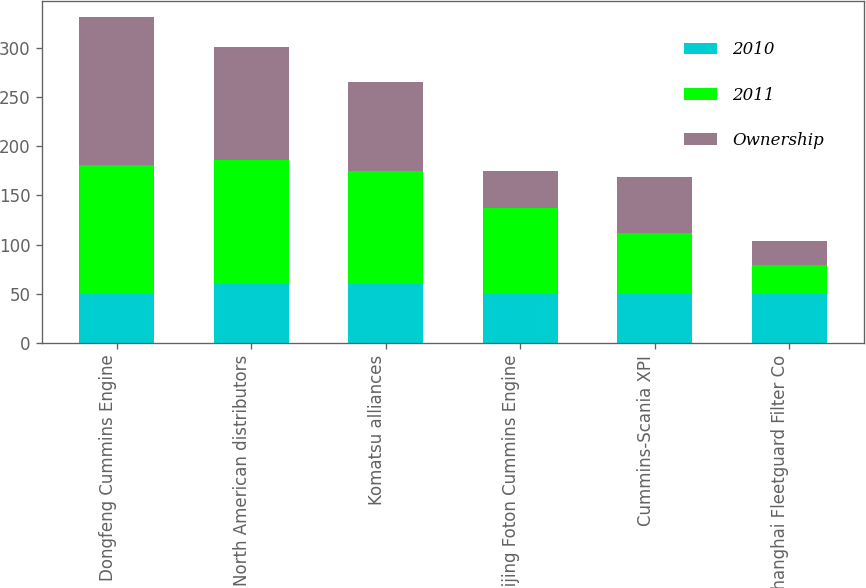Convert chart. <chart><loc_0><loc_0><loc_500><loc_500><stacked_bar_chart><ecel><fcel>Dongfeng Cummins Engine<fcel>North American distributors<fcel>Komatsu alliances<fcel>Beijing Foton Cummins Engine<fcel>Cummins-Scania XPI<fcel>Shanghai Fleetguard Filter Co<nl><fcel>2010<fcel>50<fcel>59.5<fcel>59.5<fcel>50<fcel>50<fcel>50<nl><fcel>2011<fcel>131<fcel>127<fcel>115<fcel>87<fcel>62<fcel>29<nl><fcel>Ownership<fcel>150<fcel>114<fcel>91<fcel>38<fcel>57<fcel>25<nl></chart> 